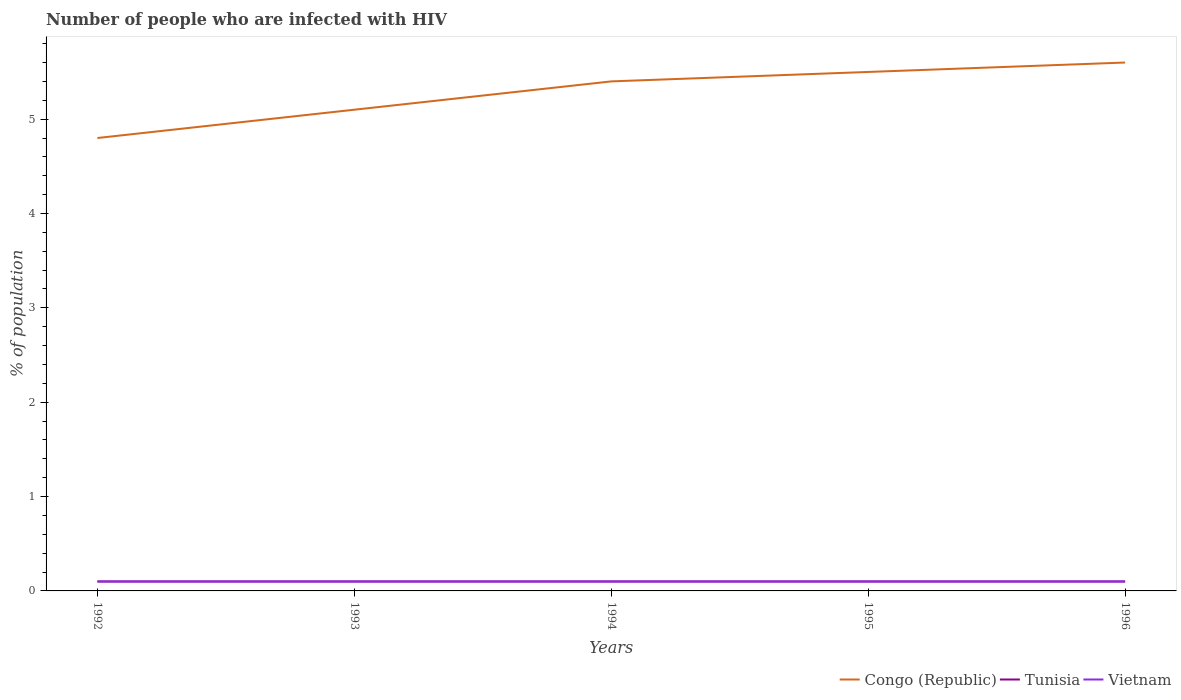Does the line corresponding to Congo (Republic) intersect with the line corresponding to Vietnam?
Your answer should be very brief. No. Across all years, what is the maximum percentage of HIV infected population in in Congo (Republic)?
Ensure brevity in your answer.  4.8. In which year was the percentage of HIV infected population in in Vietnam maximum?
Ensure brevity in your answer.  1992. What is the total percentage of HIV infected population in in Vietnam in the graph?
Provide a succinct answer. 0. What is the difference between the highest and the second highest percentage of HIV infected population in in Tunisia?
Your response must be concise. 0. Is the percentage of HIV infected population in in Congo (Republic) strictly greater than the percentage of HIV infected population in in Vietnam over the years?
Provide a succinct answer. No. How many lines are there?
Provide a succinct answer. 3. How many years are there in the graph?
Give a very brief answer. 5. What is the difference between two consecutive major ticks on the Y-axis?
Provide a succinct answer. 1. Does the graph contain any zero values?
Your answer should be compact. No. Does the graph contain grids?
Ensure brevity in your answer.  No. Where does the legend appear in the graph?
Make the answer very short. Bottom right. How many legend labels are there?
Ensure brevity in your answer.  3. How are the legend labels stacked?
Give a very brief answer. Horizontal. What is the title of the graph?
Offer a very short reply. Number of people who are infected with HIV. Does "Sint Maarten (Dutch part)" appear as one of the legend labels in the graph?
Your answer should be compact. No. What is the label or title of the Y-axis?
Your answer should be very brief. % of population. What is the % of population of Congo (Republic) in 1992?
Provide a succinct answer. 4.8. What is the % of population of Vietnam in 1992?
Ensure brevity in your answer.  0.1. What is the % of population of Tunisia in 1993?
Your answer should be compact. 0.1. What is the % of population in Vietnam in 1993?
Provide a succinct answer. 0.1. What is the % of population of Vietnam in 1994?
Offer a very short reply. 0.1. What is the % of population in Tunisia in 1995?
Provide a short and direct response. 0.1. What is the % of population in Vietnam in 1995?
Your answer should be compact. 0.1. What is the % of population in Vietnam in 1996?
Offer a terse response. 0.1. Across all years, what is the maximum % of population of Congo (Republic)?
Make the answer very short. 5.6. Across all years, what is the maximum % of population in Tunisia?
Provide a succinct answer. 0.1. Across all years, what is the maximum % of population of Vietnam?
Ensure brevity in your answer.  0.1. Across all years, what is the minimum % of population in Congo (Republic)?
Make the answer very short. 4.8. Across all years, what is the minimum % of population of Vietnam?
Your answer should be very brief. 0.1. What is the total % of population of Congo (Republic) in the graph?
Ensure brevity in your answer.  26.4. What is the total % of population in Tunisia in the graph?
Make the answer very short. 0.5. What is the difference between the % of population in Congo (Republic) in 1992 and that in 1993?
Ensure brevity in your answer.  -0.3. What is the difference between the % of population in Tunisia in 1992 and that in 1993?
Offer a very short reply. 0. What is the difference between the % of population in Vietnam in 1992 and that in 1993?
Your response must be concise. 0. What is the difference between the % of population of Tunisia in 1992 and that in 1994?
Your answer should be compact. 0. What is the difference between the % of population in Congo (Republic) in 1992 and that in 1995?
Ensure brevity in your answer.  -0.7. What is the difference between the % of population of Vietnam in 1992 and that in 1995?
Give a very brief answer. 0. What is the difference between the % of population of Congo (Republic) in 1992 and that in 1996?
Your response must be concise. -0.8. What is the difference between the % of population of Tunisia in 1992 and that in 1996?
Keep it short and to the point. 0. What is the difference between the % of population in Tunisia in 1993 and that in 1995?
Provide a short and direct response. 0. What is the difference between the % of population in Vietnam in 1993 and that in 1995?
Your response must be concise. 0. What is the difference between the % of population in Congo (Republic) in 1993 and that in 1996?
Give a very brief answer. -0.5. What is the difference between the % of population in Vietnam in 1994 and that in 1995?
Offer a terse response. 0. What is the difference between the % of population in Congo (Republic) in 1994 and that in 1996?
Provide a short and direct response. -0.2. What is the difference between the % of population in Congo (Republic) in 1995 and that in 1996?
Offer a terse response. -0.1. What is the difference between the % of population in Congo (Republic) in 1992 and the % of population in Tunisia in 1993?
Your answer should be compact. 4.7. What is the difference between the % of population of Congo (Republic) in 1992 and the % of population of Vietnam in 1993?
Provide a succinct answer. 4.7. What is the difference between the % of population in Congo (Republic) in 1992 and the % of population in Vietnam in 1994?
Your answer should be very brief. 4.7. What is the difference between the % of population of Congo (Republic) in 1992 and the % of population of Tunisia in 1995?
Give a very brief answer. 4.7. What is the difference between the % of population of Congo (Republic) in 1992 and the % of population of Tunisia in 1996?
Your response must be concise. 4.7. What is the difference between the % of population of Congo (Republic) in 1992 and the % of population of Vietnam in 1996?
Offer a very short reply. 4.7. What is the difference between the % of population in Tunisia in 1992 and the % of population in Vietnam in 1996?
Offer a very short reply. 0. What is the difference between the % of population in Congo (Republic) in 1993 and the % of population in Tunisia in 1994?
Ensure brevity in your answer.  5. What is the difference between the % of population of Congo (Republic) in 1993 and the % of population of Vietnam in 1994?
Your answer should be very brief. 5. What is the difference between the % of population of Tunisia in 1993 and the % of population of Vietnam in 1994?
Give a very brief answer. 0. What is the difference between the % of population in Congo (Republic) in 1993 and the % of population in Tunisia in 1996?
Provide a succinct answer. 5. What is the difference between the % of population of Tunisia in 1994 and the % of population of Vietnam in 1996?
Offer a terse response. 0. What is the difference between the % of population in Congo (Republic) in 1995 and the % of population in Tunisia in 1996?
Provide a succinct answer. 5.4. What is the average % of population in Congo (Republic) per year?
Give a very brief answer. 5.28. What is the average % of population of Tunisia per year?
Make the answer very short. 0.1. What is the average % of population in Vietnam per year?
Offer a very short reply. 0.1. In the year 1992, what is the difference between the % of population in Tunisia and % of population in Vietnam?
Provide a short and direct response. 0. In the year 1993, what is the difference between the % of population in Congo (Republic) and % of population in Vietnam?
Your response must be concise. 5. In the year 1994, what is the difference between the % of population of Congo (Republic) and % of population of Tunisia?
Offer a very short reply. 5.3. In the year 1994, what is the difference between the % of population in Congo (Republic) and % of population in Vietnam?
Keep it short and to the point. 5.3. In the year 1994, what is the difference between the % of population of Tunisia and % of population of Vietnam?
Give a very brief answer. 0. In the year 1996, what is the difference between the % of population in Congo (Republic) and % of population in Tunisia?
Your answer should be very brief. 5.5. In the year 1996, what is the difference between the % of population in Congo (Republic) and % of population in Vietnam?
Keep it short and to the point. 5.5. What is the ratio of the % of population of Tunisia in 1992 to that in 1993?
Make the answer very short. 1. What is the ratio of the % of population of Vietnam in 1992 to that in 1993?
Provide a succinct answer. 1. What is the ratio of the % of population in Congo (Republic) in 1992 to that in 1994?
Offer a terse response. 0.89. What is the ratio of the % of population in Tunisia in 1992 to that in 1994?
Keep it short and to the point. 1. What is the ratio of the % of population of Congo (Republic) in 1992 to that in 1995?
Your answer should be compact. 0.87. What is the ratio of the % of population of Vietnam in 1992 to that in 1995?
Make the answer very short. 1. What is the ratio of the % of population of Vietnam in 1992 to that in 1996?
Offer a terse response. 1. What is the ratio of the % of population in Congo (Republic) in 1993 to that in 1995?
Offer a terse response. 0.93. What is the ratio of the % of population in Tunisia in 1993 to that in 1995?
Ensure brevity in your answer.  1. What is the ratio of the % of population in Congo (Republic) in 1993 to that in 1996?
Give a very brief answer. 0.91. What is the ratio of the % of population in Tunisia in 1993 to that in 1996?
Offer a terse response. 1. What is the ratio of the % of population in Congo (Republic) in 1994 to that in 1995?
Offer a terse response. 0.98. What is the ratio of the % of population of Vietnam in 1994 to that in 1995?
Keep it short and to the point. 1. What is the ratio of the % of population in Congo (Republic) in 1994 to that in 1996?
Provide a short and direct response. 0.96. What is the ratio of the % of population of Tunisia in 1994 to that in 1996?
Ensure brevity in your answer.  1. What is the ratio of the % of population in Congo (Republic) in 1995 to that in 1996?
Your response must be concise. 0.98. What is the difference between the highest and the second highest % of population of Vietnam?
Your response must be concise. 0. What is the difference between the highest and the lowest % of population in Vietnam?
Keep it short and to the point. 0. 